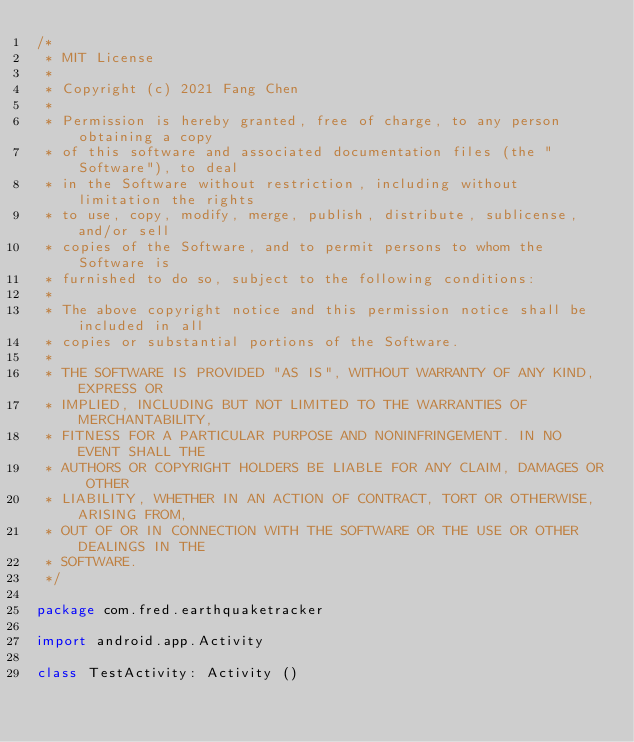<code> <loc_0><loc_0><loc_500><loc_500><_Kotlin_>/*
 * MIT License
 *
 * Copyright (c) 2021 Fang Chen
 *
 * Permission is hereby granted, free of charge, to any person obtaining a copy
 * of this software and associated documentation files (the "Software"), to deal
 * in the Software without restriction, including without limitation the rights
 * to use, copy, modify, merge, publish, distribute, sublicense, and/or sell
 * copies of the Software, and to permit persons to whom the Software is
 * furnished to do so, subject to the following conditions:
 *
 * The above copyright notice and this permission notice shall be included in all
 * copies or substantial portions of the Software.
 *
 * THE SOFTWARE IS PROVIDED "AS IS", WITHOUT WARRANTY OF ANY KIND, EXPRESS OR
 * IMPLIED, INCLUDING BUT NOT LIMITED TO THE WARRANTIES OF MERCHANTABILITY,
 * FITNESS FOR A PARTICULAR PURPOSE AND NONINFRINGEMENT. IN NO EVENT SHALL THE
 * AUTHORS OR COPYRIGHT HOLDERS BE LIABLE FOR ANY CLAIM, DAMAGES OR OTHER
 * LIABILITY, WHETHER IN AN ACTION OF CONTRACT, TORT OR OTHERWISE, ARISING FROM,
 * OUT OF OR IN CONNECTION WITH THE SOFTWARE OR THE USE OR OTHER DEALINGS IN THE
 * SOFTWARE.
 */

package com.fred.earthquaketracker

import android.app.Activity

class TestActivity: Activity ()</code> 